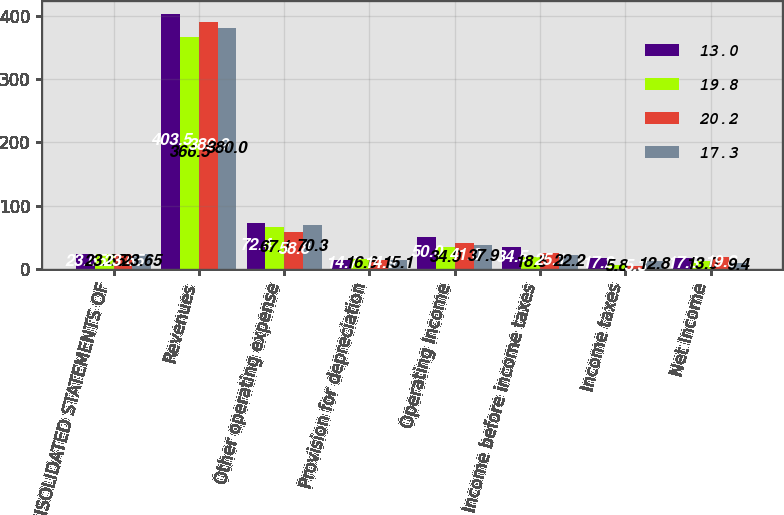Convert chart to OTSL. <chart><loc_0><loc_0><loc_500><loc_500><stacked_bar_chart><ecel><fcel>CONSOLIDATED STATEMENTS OF<fcel>Revenues<fcel>Other operating expense<fcel>Provision for depreciation<fcel>Operating Income<fcel>Income before income taxes<fcel>Income taxes<fcel>Net Income<nl><fcel>13<fcel>23.65<fcel>403.5<fcel>72.4<fcel>14.7<fcel>50<fcel>34.5<fcel>17.2<fcel>17.3<nl><fcel>19.8<fcel>23.65<fcel>366.5<fcel>67.1<fcel>16.6<fcel>34.9<fcel>18.8<fcel>5.8<fcel>13<nl><fcel>20.2<fcel>23.65<fcel>389.9<fcel>58.8<fcel>14.9<fcel>41<fcel>25.1<fcel>5.3<fcel>19.8<nl><fcel>17.3<fcel>23.65<fcel>380<fcel>70.3<fcel>15.1<fcel>37.9<fcel>22.2<fcel>12.8<fcel>9.4<nl></chart> 